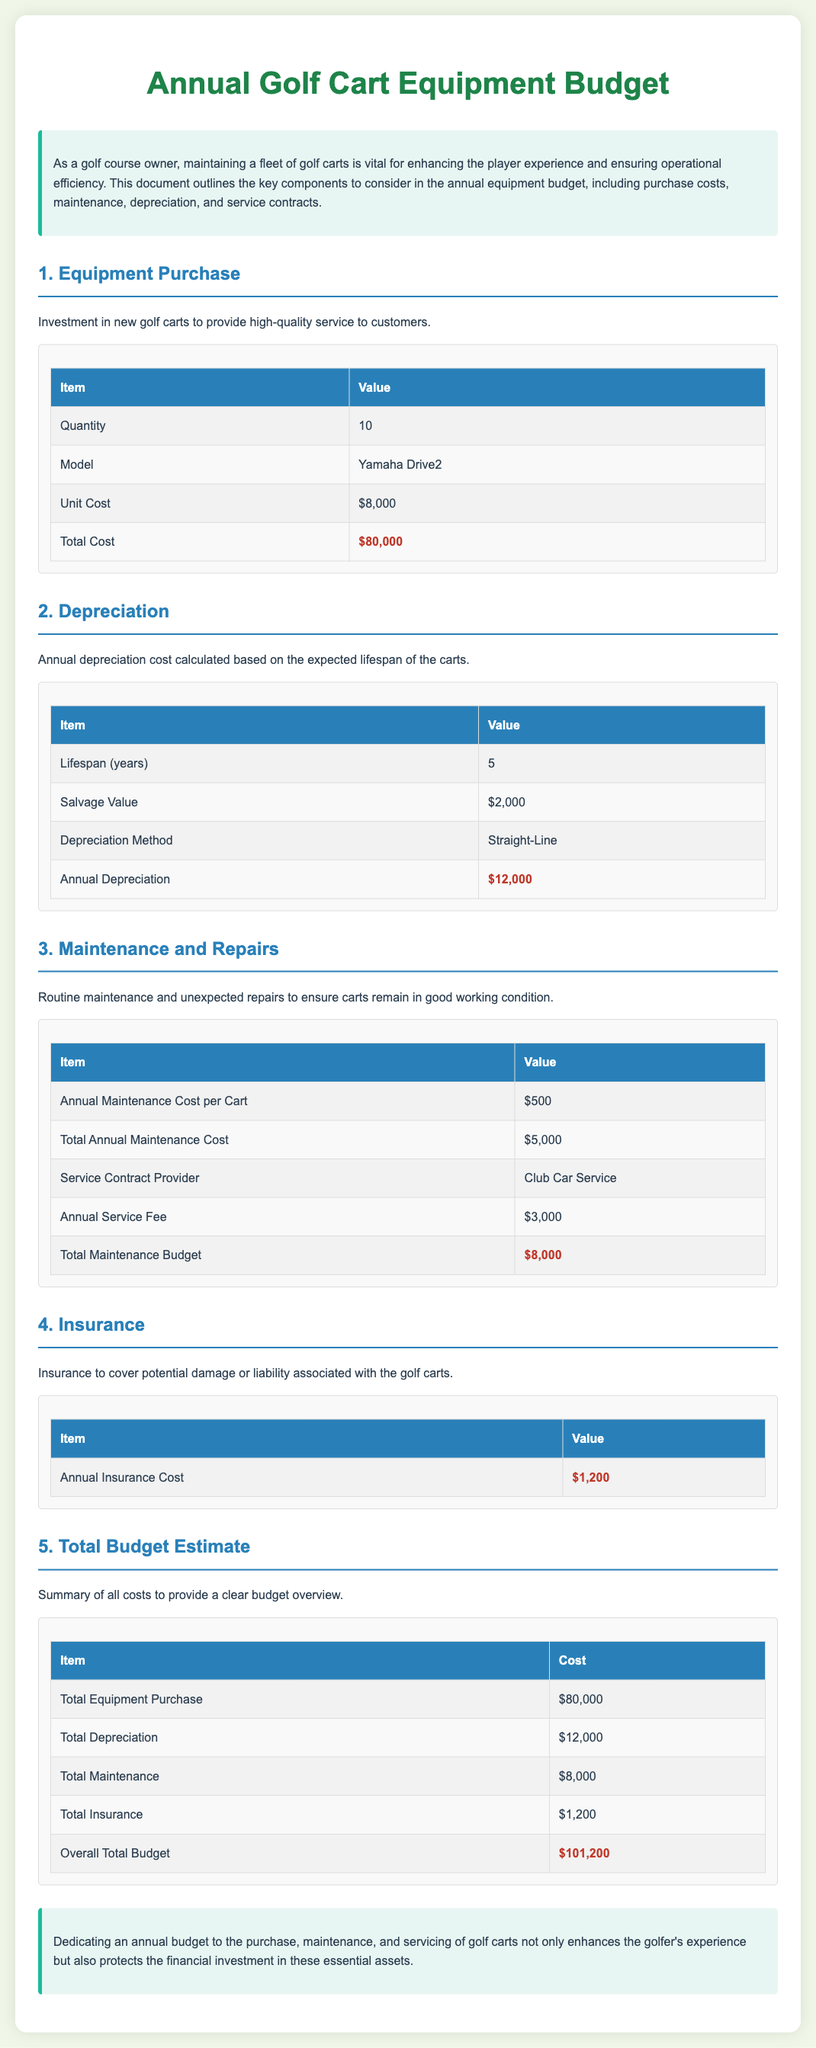What is the model of the golf carts? The document specifies that the model of the golf carts is Yamaha Drive2.
Answer: Yamaha Drive2 How many golf carts are being purchased? The quantity of golf carts specified in the document is 10.
Answer: 10 What is the total cost for purchasing the golf carts? The total cost for purchasing the golf carts is indicated as $80,000.
Answer: $80,000 What is the annual depreciation cost? The annual depreciation cost calculated based on the carts' expected lifespan is $12,000.
Answer: $12,000 What is the annual maintenance cost per cart? The document states that the annual maintenance cost per cart is $500.
Answer: $500 Who is the service contract provider? The service contract provider mentioned in the document is Club Car Service.
Answer: Club Car Service What is the total maintenance budget? The total maintenance budget outlined in the document is $8,000.
Answer: $8,000 What is the annual insurance cost? The document specifies that the annual insurance cost is $1,200.
Answer: $1,200 What is the overall total budget? The overall total budget calculated in the document is $101,200.
Answer: $101,200 